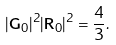Convert formula to latex. <formula><loc_0><loc_0><loc_500><loc_500>| { \mathbf G } _ { 0 } | ^ { 2 } | { \mathbf R } _ { 0 } | ^ { 2 } = \frac { 4 } { 3 } .</formula> 